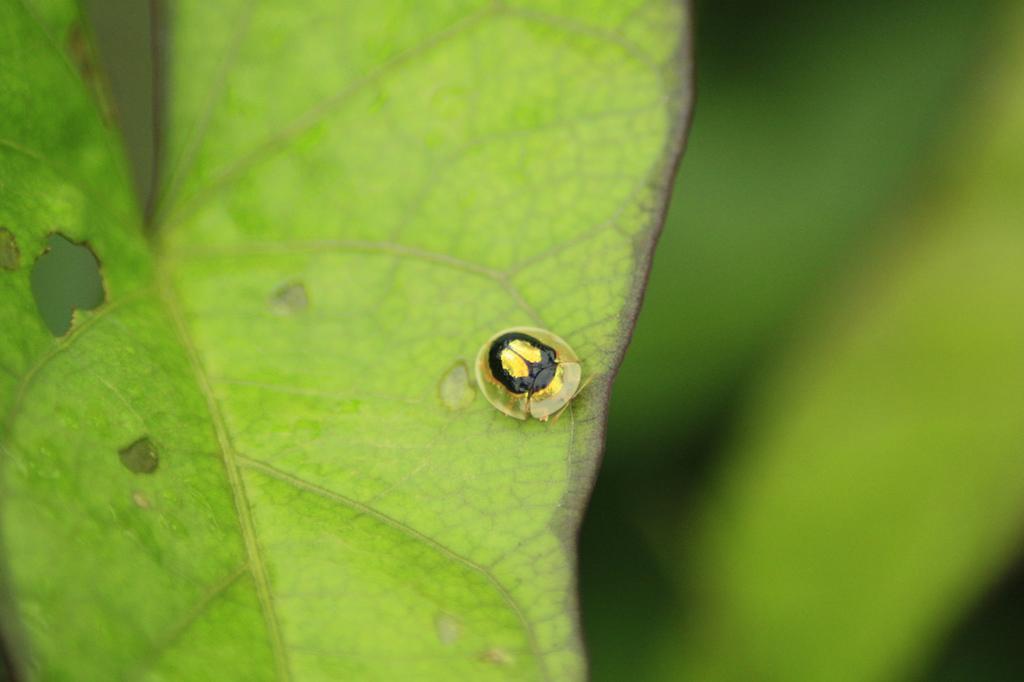How would you summarize this image in a sentence or two? In this image I can see a green colour leaf in the front and on it I can see a black colour insect. 